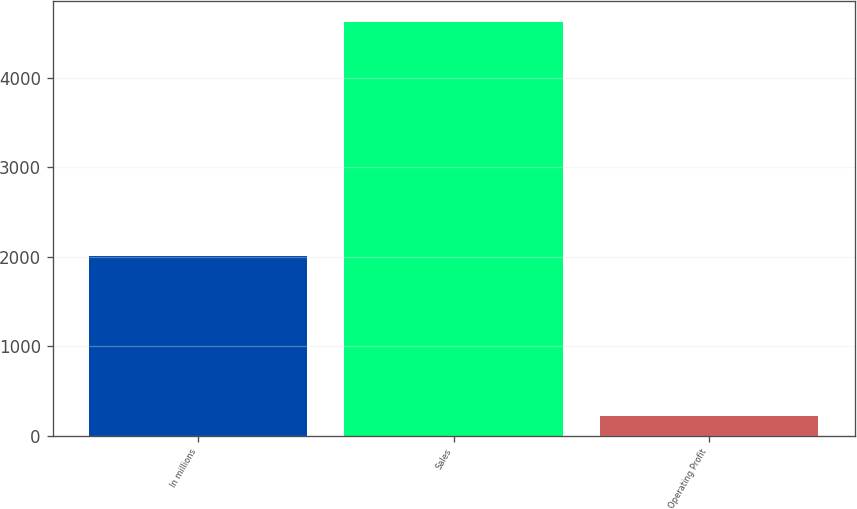Convert chart. <chart><loc_0><loc_0><loc_500><loc_500><bar_chart><fcel>In millions<fcel>Sales<fcel>Operating Profit<nl><fcel>2005<fcel>4625<fcel>219<nl></chart> 